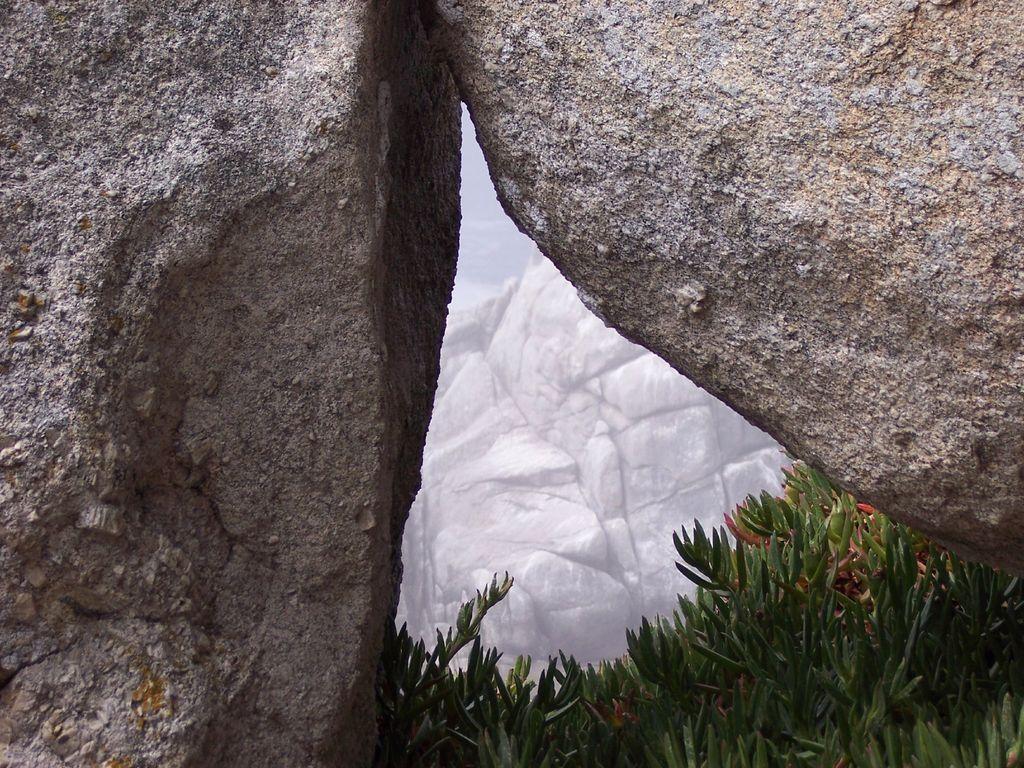Describe this image in one or two sentences. In this picture we can see few plants and rocks. 